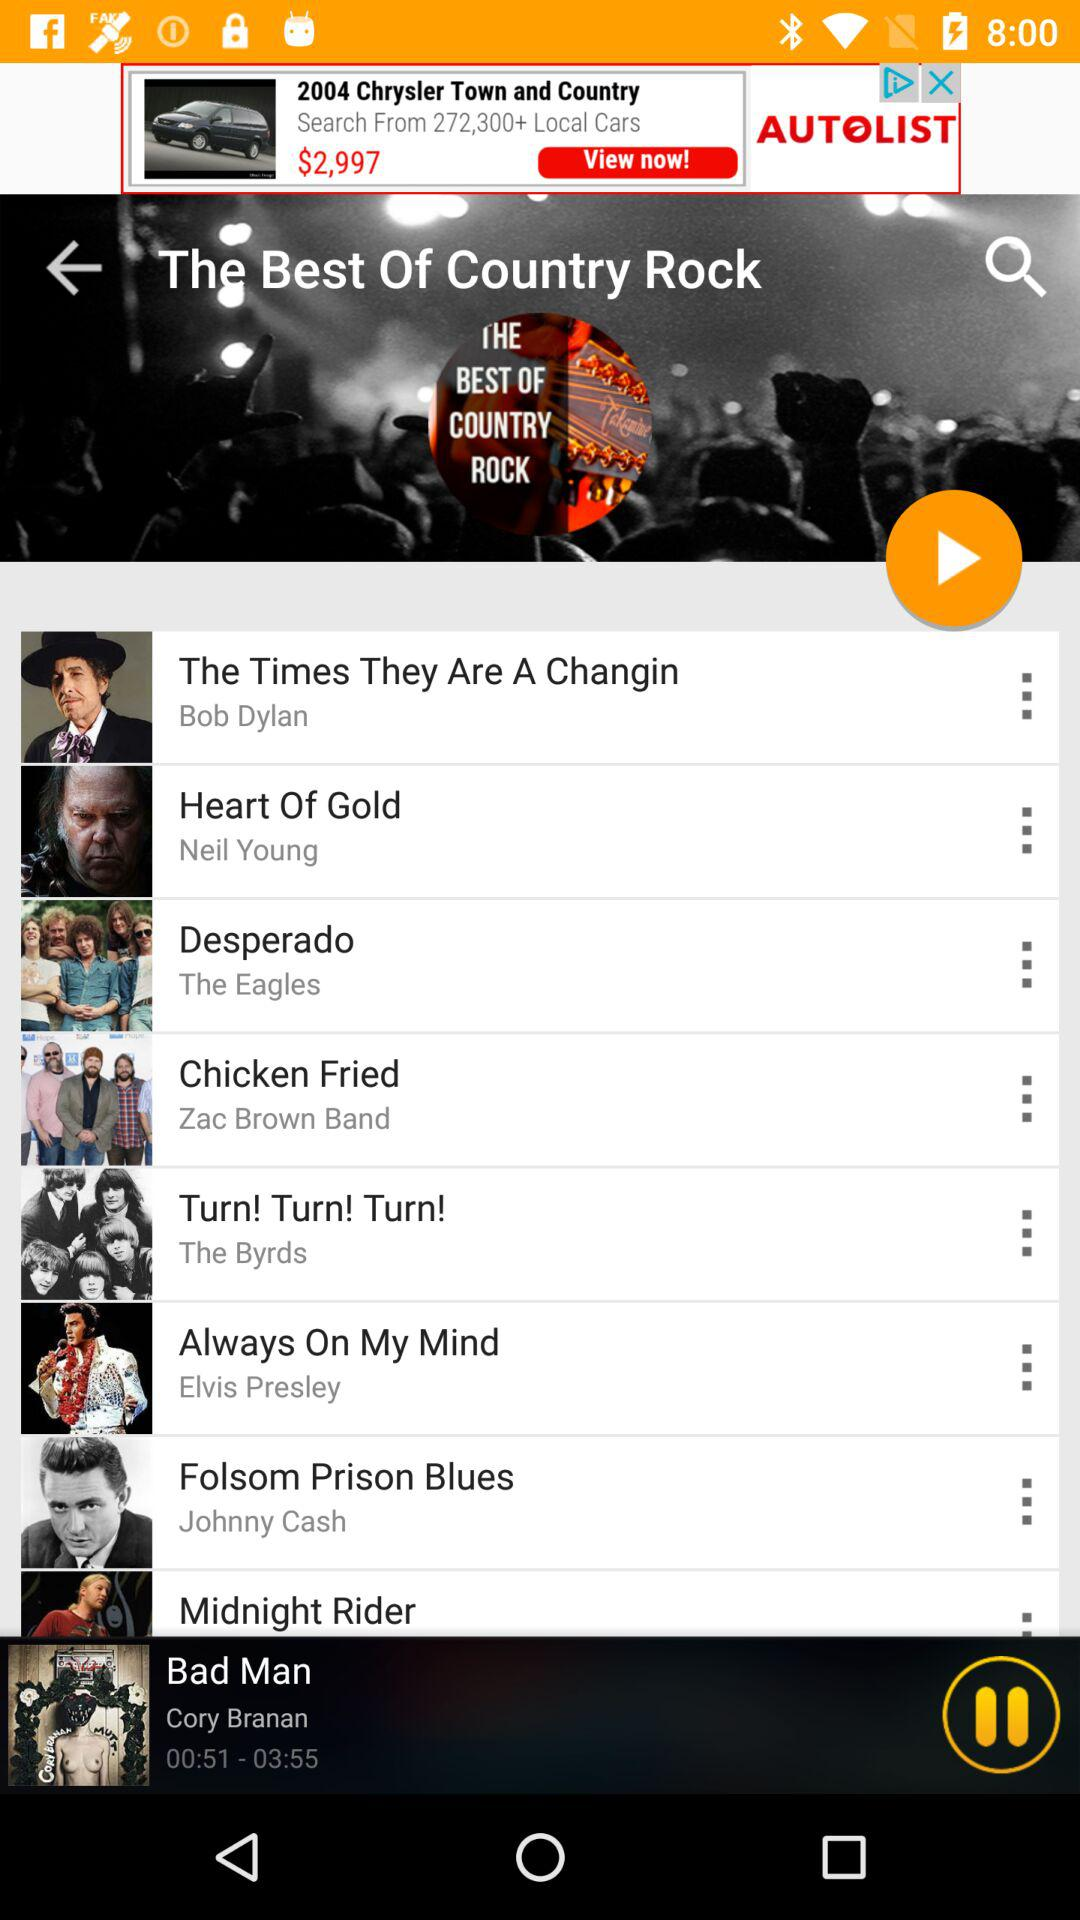Which song is playing now? The song that is playing now is "Bad Man". 